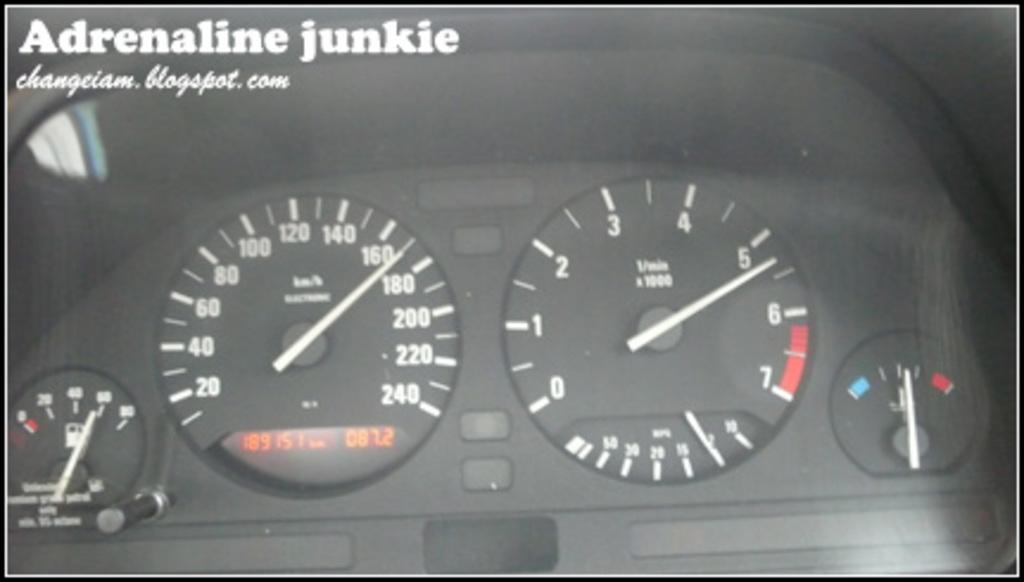What is the main object in the image? There is a speedometer in the image. What is the primary function of the speedometer? The speedometer is used to measure and display the speed of a vehicle. Can you describe the appearance of the speedometer? The appearance of the speedometer may vary depending on the vehicle it is in, but it typically consists of a dial with numbers indicating different speeds and a needle that moves to indicate the current speed. What type of authority figure is depicted on the roof in the image? There is no authority figure or roof present in the image; it only features a speedometer. 